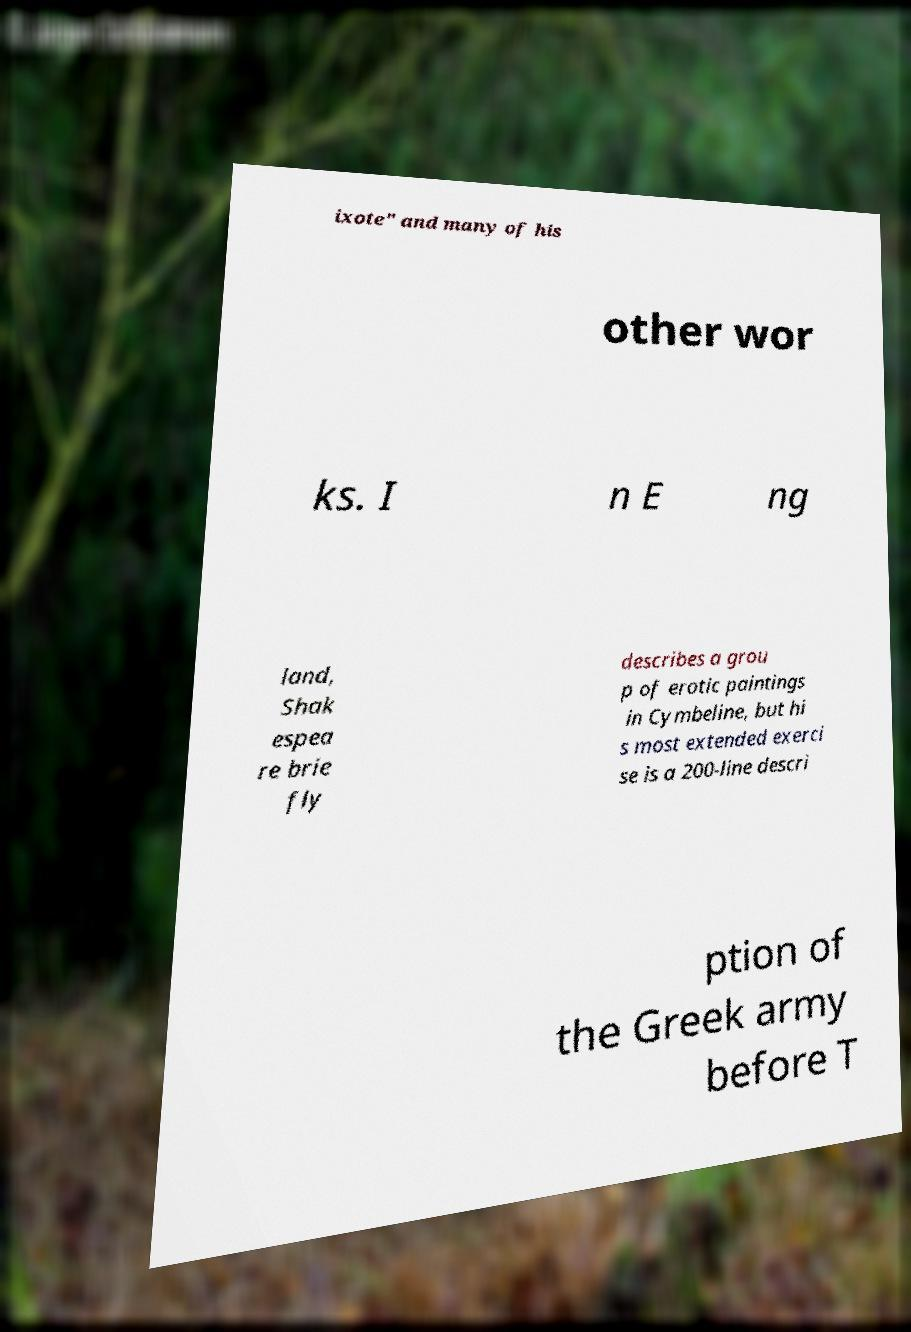Can you read and provide the text displayed in the image?This photo seems to have some interesting text. Can you extract and type it out for me? ixote" and many of his other wor ks. I n E ng land, Shak espea re brie fly describes a grou p of erotic paintings in Cymbeline, but hi s most extended exerci se is a 200-line descri ption of the Greek army before T 